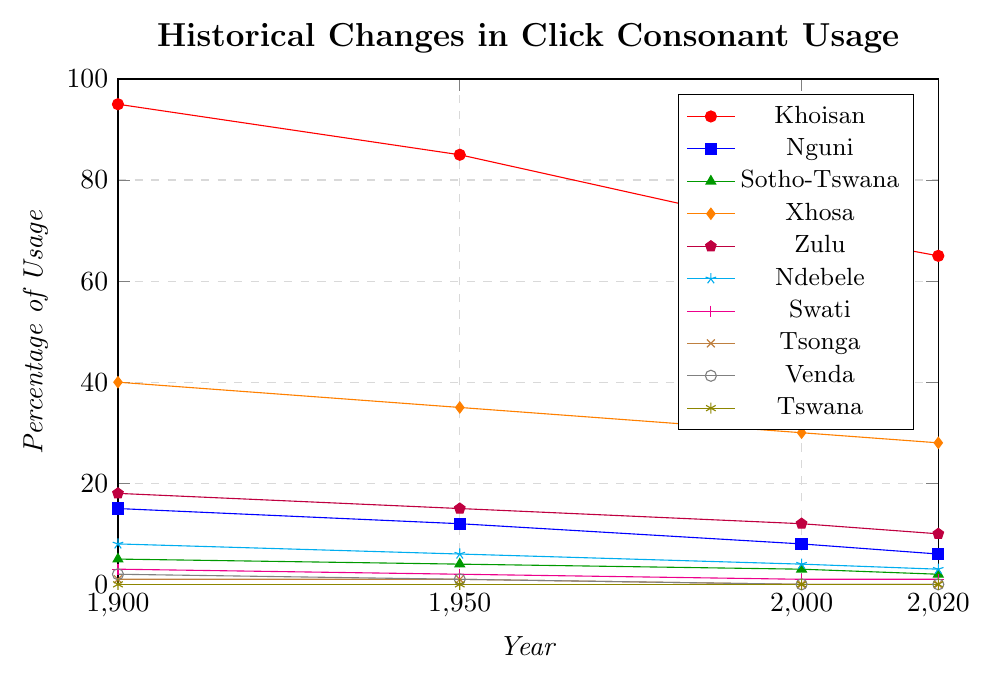Which language group had the highest percentage of click consonant usage in 2000? The figure shows that in 2000, the Khoisan group had the highest percentage of click consonant usage.
Answer: Khoisan Which language group shows the greatest decline in percentage usage of click consonants from 1900 to 2020? To find this, check the beginning and end values for each language group in the figure. Khoisan drops from 95% to 65%, a decrease of 30%, which is the most significant decline.
Answer: Khoisan Which two language groups had no click consonant usage by 2020? By observing the plot at the year 2020, we see that Tsonga and Venda both reached 0% usage of click consonants.
Answer: Tsonga and Venda What is the combined percentage usage of click consonants for Xhosa and Zulu in 2020? In 2020, Xhosa has 28% and Zulu has 10%. Summing these gives 38%.
Answer: 38% Did any language group maintain a constant percentage usage of click consonants across all recorded years? From the plot, Swati maintains a percentage range from 3% in 1900 to 1% in 2020, but it does show a decrease, though minimal. No group maintained a constant value across all years.
Answer: No How did the usage of click consonants in the Nguni language group change from 1900 to 2020? The plot shows Nguni starting at 15% in 1900 and decreasing to 6% in 2020. This is a decrease of 9%.
Answer: Decreased by 9% Which language group had the smallest change in click consonant usage from 2000 to 2020? By observing the slopes from 2000 to 2020 in the plot, Swati changes from 1% to 1%, showing no change.
Answer: Swati In which decade did the Ndebele language group see the largest decrease in click consonant usage? Ndebele’s plot shows the largest decrease occurring between 1900 and 1950, from 8% to 6%.
Answer: 1900 to 1950 If we average the percentage usage of click consonants for the Khoisan group across all four years, what do we get? Summing the Khoisan values (95 + 85 + 70 + 65) = 315 and averaging over 4 gives 315 / 4 = 78.75%
Answer: 78.75% Which language group had a percentage usage closest to 50% at any given time? Observing the plot, we see that no group consistently hits or remains at 50%, but Xhosa is closest with 40% in 1900.
Answer: Xhosa in 1900 